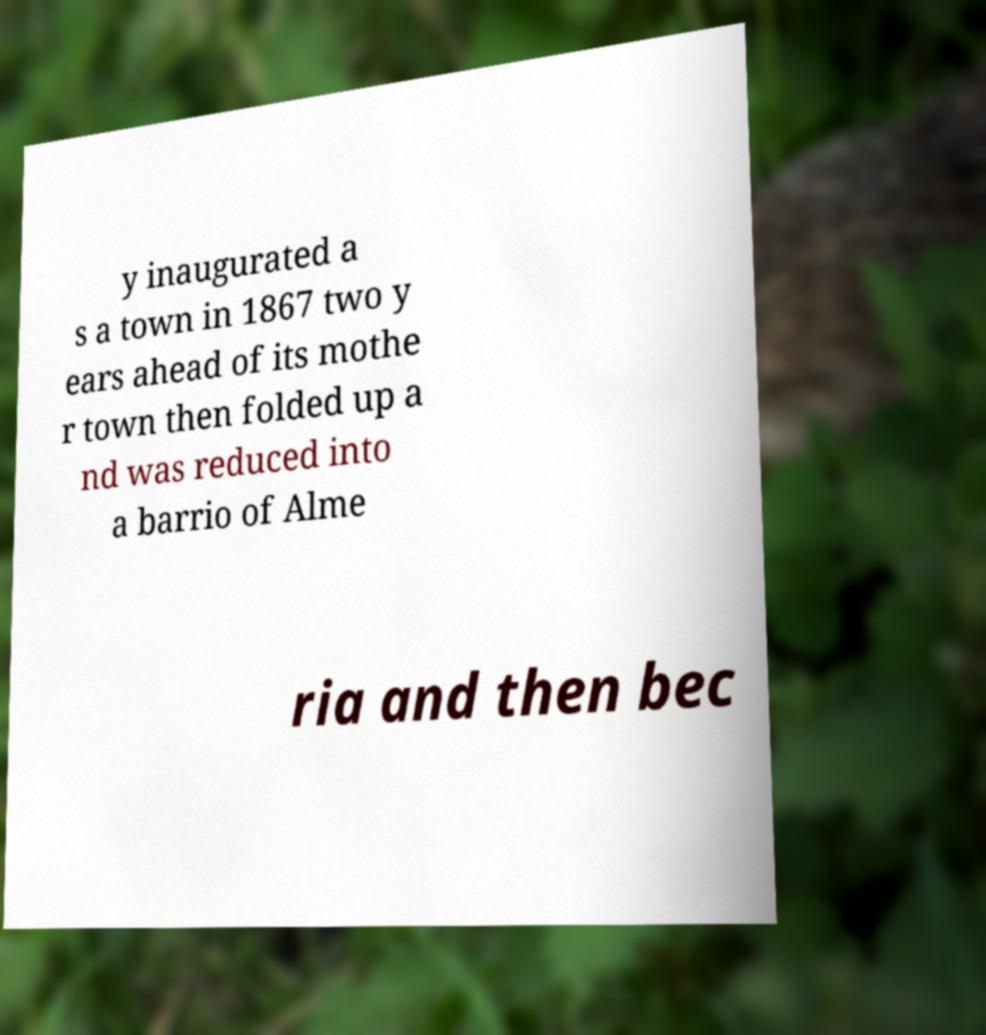Can you accurately transcribe the text from the provided image for me? y inaugurated a s a town in 1867 two y ears ahead of its mothe r town then folded up a nd was reduced into a barrio of Alme ria and then bec 